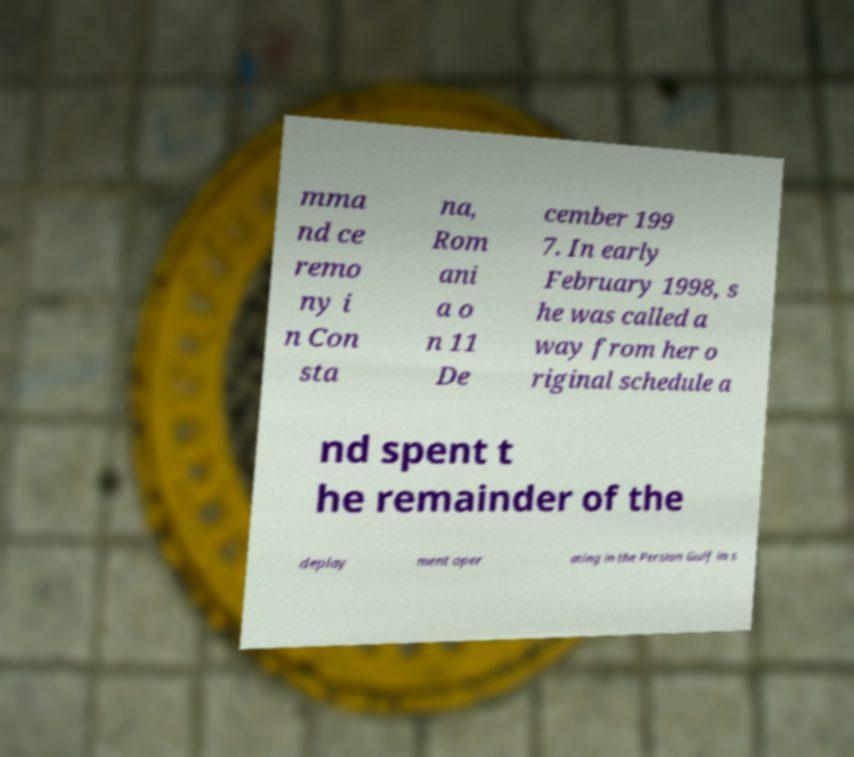For documentation purposes, I need the text within this image transcribed. Could you provide that? mma nd ce remo ny i n Con sta na, Rom ani a o n 11 De cember 199 7. In early February 1998, s he was called a way from her o riginal schedule a nd spent t he remainder of the deploy ment oper ating in the Persian Gulf in s 